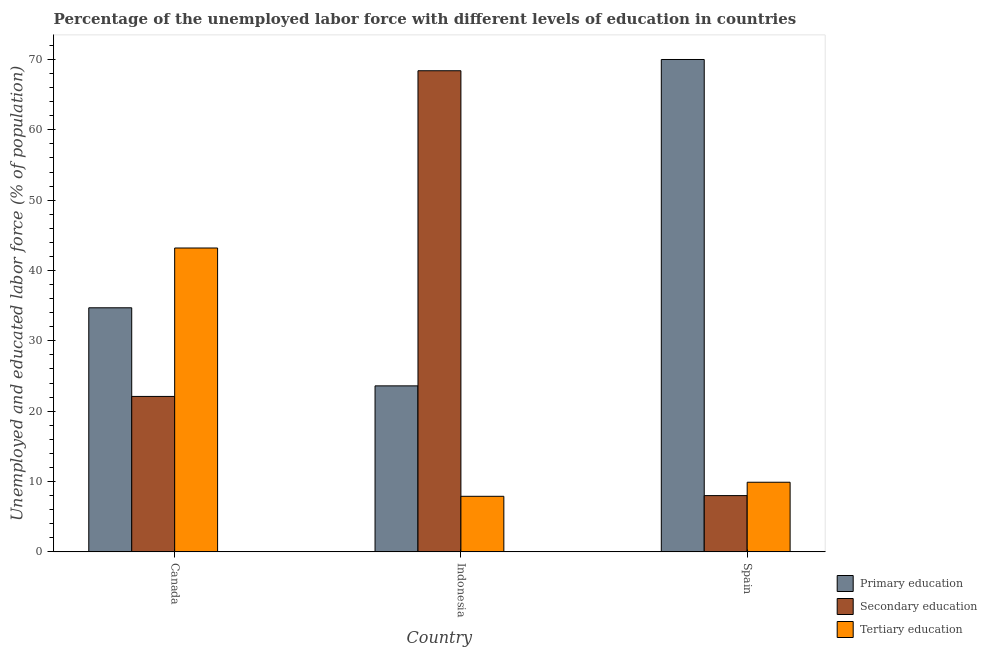Are the number of bars per tick equal to the number of legend labels?
Offer a terse response. Yes. How many bars are there on the 1st tick from the right?
Your response must be concise. 3. In how many cases, is the number of bars for a given country not equal to the number of legend labels?
Keep it short and to the point. 0. What is the percentage of labor force who received primary education in Indonesia?
Your answer should be very brief. 23.6. Across all countries, what is the maximum percentage of labor force who received tertiary education?
Make the answer very short. 43.2. Across all countries, what is the minimum percentage of labor force who received secondary education?
Provide a short and direct response. 8. In which country was the percentage of labor force who received tertiary education minimum?
Make the answer very short. Indonesia. What is the total percentage of labor force who received tertiary education in the graph?
Make the answer very short. 61. What is the difference between the percentage of labor force who received primary education in Canada and that in Indonesia?
Keep it short and to the point. 11.1. What is the difference between the percentage of labor force who received secondary education in Indonesia and the percentage of labor force who received primary education in Spain?
Give a very brief answer. -1.6. What is the average percentage of labor force who received primary education per country?
Your answer should be compact. 42.77. What is the difference between the percentage of labor force who received secondary education and percentage of labor force who received tertiary education in Spain?
Provide a succinct answer. -1.9. What is the ratio of the percentage of labor force who received primary education in Canada to that in Spain?
Provide a short and direct response. 0.5. Is the percentage of labor force who received primary education in Canada less than that in Indonesia?
Your answer should be compact. No. What is the difference between the highest and the second highest percentage of labor force who received secondary education?
Give a very brief answer. 46.3. What is the difference between the highest and the lowest percentage of labor force who received tertiary education?
Keep it short and to the point. 35.3. Is the sum of the percentage of labor force who received primary education in Indonesia and Spain greater than the maximum percentage of labor force who received tertiary education across all countries?
Ensure brevity in your answer.  Yes. What does the 2nd bar from the left in Spain represents?
Give a very brief answer. Secondary education. What does the 1st bar from the right in Spain represents?
Your answer should be compact. Tertiary education. Are all the bars in the graph horizontal?
Your answer should be very brief. No. What is the difference between two consecutive major ticks on the Y-axis?
Your answer should be compact. 10. Does the graph contain any zero values?
Provide a succinct answer. No. Does the graph contain grids?
Your answer should be compact. No. Where does the legend appear in the graph?
Your response must be concise. Bottom right. How many legend labels are there?
Ensure brevity in your answer.  3. What is the title of the graph?
Provide a short and direct response. Percentage of the unemployed labor force with different levels of education in countries. Does "Social Insurance" appear as one of the legend labels in the graph?
Keep it short and to the point. No. What is the label or title of the X-axis?
Provide a succinct answer. Country. What is the label or title of the Y-axis?
Give a very brief answer. Unemployed and educated labor force (% of population). What is the Unemployed and educated labor force (% of population) in Primary education in Canada?
Provide a succinct answer. 34.7. What is the Unemployed and educated labor force (% of population) of Secondary education in Canada?
Offer a terse response. 22.1. What is the Unemployed and educated labor force (% of population) in Tertiary education in Canada?
Offer a terse response. 43.2. What is the Unemployed and educated labor force (% of population) of Primary education in Indonesia?
Your answer should be compact. 23.6. What is the Unemployed and educated labor force (% of population) of Secondary education in Indonesia?
Offer a very short reply. 68.4. What is the Unemployed and educated labor force (% of population) in Tertiary education in Indonesia?
Your response must be concise. 7.9. What is the Unemployed and educated labor force (% of population) in Primary education in Spain?
Provide a short and direct response. 70. What is the Unemployed and educated labor force (% of population) in Secondary education in Spain?
Provide a short and direct response. 8. What is the Unemployed and educated labor force (% of population) of Tertiary education in Spain?
Give a very brief answer. 9.9. Across all countries, what is the maximum Unemployed and educated labor force (% of population) in Secondary education?
Make the answer very short. 68.4. Across all countries, what is the maximum Unemployed and educated labor force (% of population) in Tertiary education?
Provide a succinct answer. 43.2. Across all countries, what is the minimum Unemployed and educated labor force (% of population) of Primary education?
Make the answer very short. 23.6. Across all countries, what is the minimum Unemployed and educated labor force (% of population) of Tertiary education?
Keep it short and to the point. 7.9. What is the total Unemployed and educated labor force (% of population) of Primary education in the graph?
Provide a short and direct response. 128.3. What is the total Unemployed and educated labor force (% of population) of Secondary education in the graph?
Give a very brief answer. 98.5. What is the difference between the Unemployed and educated labor force (% of population) in Secondary education in Canada and that in Indonesia?
Offer a terse response. -46.3. What is the difference between the Unemployed and educated labor force (% of population) in Tertiary education in Canada and that in Indonesia?
Give a very brief answer. 35.3. What is the difference between the Unemployed and educated labor force (% of population) in Primary education in Canada and that in Spain?
Make the answer very short. -35.3. What is the difference between the Unemployed and educated labor force (% of population) in Secondary education in Canada and that in Spain?
Keep it short and to the point. 14.1. What is the difference between the Unemployed and educated labor force (% of population) in Tertiary education in Canada and that in Spain?
Make the answer very short. 33.3. What is the difference between the Unemployed and educated labor force (% of population) in Primary education in Indonesia and that in Spain?
Your answer should be compact. -46.4. What is the difference between the Unemployed and educated labor force (% of population) of Secondary education in Indonesia and that in Spain?
Provide a short and direct response. 60.4. What is the difference between the Unemployed and educated labor force (% of population) in Tertiary education in Indonesia and that in Spain?
Make the answer very short. -2. What is the difference between the Unemployed and educated labor force (% of population) of Primary education in Canada and the Unemployed and educated labor force (% of population) of Secondary education in Indonesia?
Make the answer very short. -33.7. What is the difference between the Unemployed and educated labor force (% of population) of Primary education in Canada and the Unemployed and educated labor force (% of population) of Tertiary education in Indonesia?
Offer a very short reply. 26.8. What is the difference between the Unemployed and educated labor force (% of population) in Primary education in Canada and the Unemployed and educated labor force (% of population) in Secondary education in Spain?
Make the answer very short. 26.7. What is the difference between the Unemployed and educated labor force (% of population) in Primary education in Canada and the Unemployed and educated labor force (% of population) in Tertiary education in Spain?
Offer a very short reply. 24.8. What is the difference between the Unemployed and educated labor force (% of population) in Secondary education in Canada and the Unemployed and educated labor force (% of population) in Tertiary education in Spain?
Make the answer very short. 12.2. What is the difference between the Unemployed and educated labor force (% of population) of Primary education in Indonesia and the Unemployed and educated labor force (% of population) of Tertiary education in Spain?
Provide a short and direct response. 13.7. What is the difference between the Unemployed and educated labor force (% of population) of Secondary education in Indonesia and the Unemployed and educated labor force (% of population) of Tertiary education in Spain?
Offer a terse response. 58.5. What is the average Unemployed and educated labor force (% of population) in Primary education per country?
Offer a terse response. 42.77. What is the average Unemployed and educated labor force (% of population) of Secondary education per country?
Your answer should be very brief. 32.83. What is the average Unemployed and educated labor force (% of population) of Tertiary education per country?
Offer a terse response. 20.33. What is the difference between the Unemployed and educated labor force (% of population) of Primary education and Unemployed and educated labor force (% of population) of Secondary education in Canada?
Offer a very short reply. 12.6. What is the difference between the Unemployed and educated labor force (% of population) in Secondary education and Unemployed and educated labor force (% of population) in Tertiary education in Canada?
Provide a short and direct response. -21.1. What is the difference between the Unemployed and educated labor force (% of population) in Primary education and Unemployed and educated labor force (% of population) in Secondary education in Indonesia?
Offer a very short reply. -44.8. What is the difference between the Unemployed and educated labor force (% of population) in Primary education and Unemployed and educated labor force (% of population) in Tertiary education in Indonesia?
Your response must be concise. 15.7. What is the difference between the Unemployed and educated labor force (% of population) of Secondary education and Unemployed and educated labor force (% of population) of Tertiary education in Indonesia?
Provide a short and direct response. 60.5. What is the difference between the Unemployed and educated labor force (% of population) of Primary education and Unemployed and educated labor force (% of population) of Tertiary education in Spain?
Offer a very short reply. 60.1. What is the difference between the Unemployed and educated labor force (% of population) in Secondary education and Unemployed and educated labor force (% of population) in Tertiary education in Spain?
Make the answer very short. -1.9. What is the ratio of the Unemployed and educated labor force (% of population) in Primary education in Canada to that in Indonesia?
Offer a terse response. 1.47. What is the ratio of the Unemployed and educated labor force (% of population) in Secondary education in Canada to that in Indonesia?
Your response must be concise. 0.32. What is the ratio of the Unemployed and educated labor force (% of population) in Tertiary education in Canada to that in Indonesia?
Provide a succinct answer. 5.47. What is the ratio of the Unemployed and educated labor force (% of population) in Primary education in Canada to that in Spain?
Keep it short and to the point. 0.5. What is the ratio of the Unemployed and educated labor force (% of population) in Secondary education in Canada to that in Spain?
Make the answer very short. 2.76. What is the ratio of the Unemployed and educated labor force (% of population) in Tertiary education in Canada to that in Spain?
Offer a very short reply. 4.36. What is the ratio of the Unemployed and educated labor force (% of population) of Primary education in Indonesia to that in Spain?
Offer a very short reply. 0.34. What is the ratio of the Unemployed and educated labor force (% of population) of Secondary education in Indonesia to that in Spain?
Give a very brief answer. 8.55. What is the ratio of the Unemployed and educated labor force (% of population) of Tertiary education in Indonesia to that in Spain?
Give a very brief answer. 0.8. What is the difference between the highest and the second highest Unemployed and educated labor force (% of population) in Primary education?
Provide a short and direct response. 35.3. What is the difference between the highest and the second highest Unemployed and educated labor force (% of population) of Secondary education?
Provide a succinct answer. 46.3. What is the difference between the highest and the second highest Unemployed and educated labor force (% of population) of Tertiary education?
Ensure brevity in your answer.  33.3. What is the difference between the highest and the lowest Unemployed and educated labor force (% of population) in Primary education?
Provide a short and direct response. 46.4. What is the difference between the highest and the lowest Unemployed and educated labor force (% of population) of Secondary education?
Keep it short and to the point. 60.4. What is the difference between the highest and the lowest Unemployed and educated labor force (% of population) of Tertiary education?
Provide a succinct answer. 35.3. 